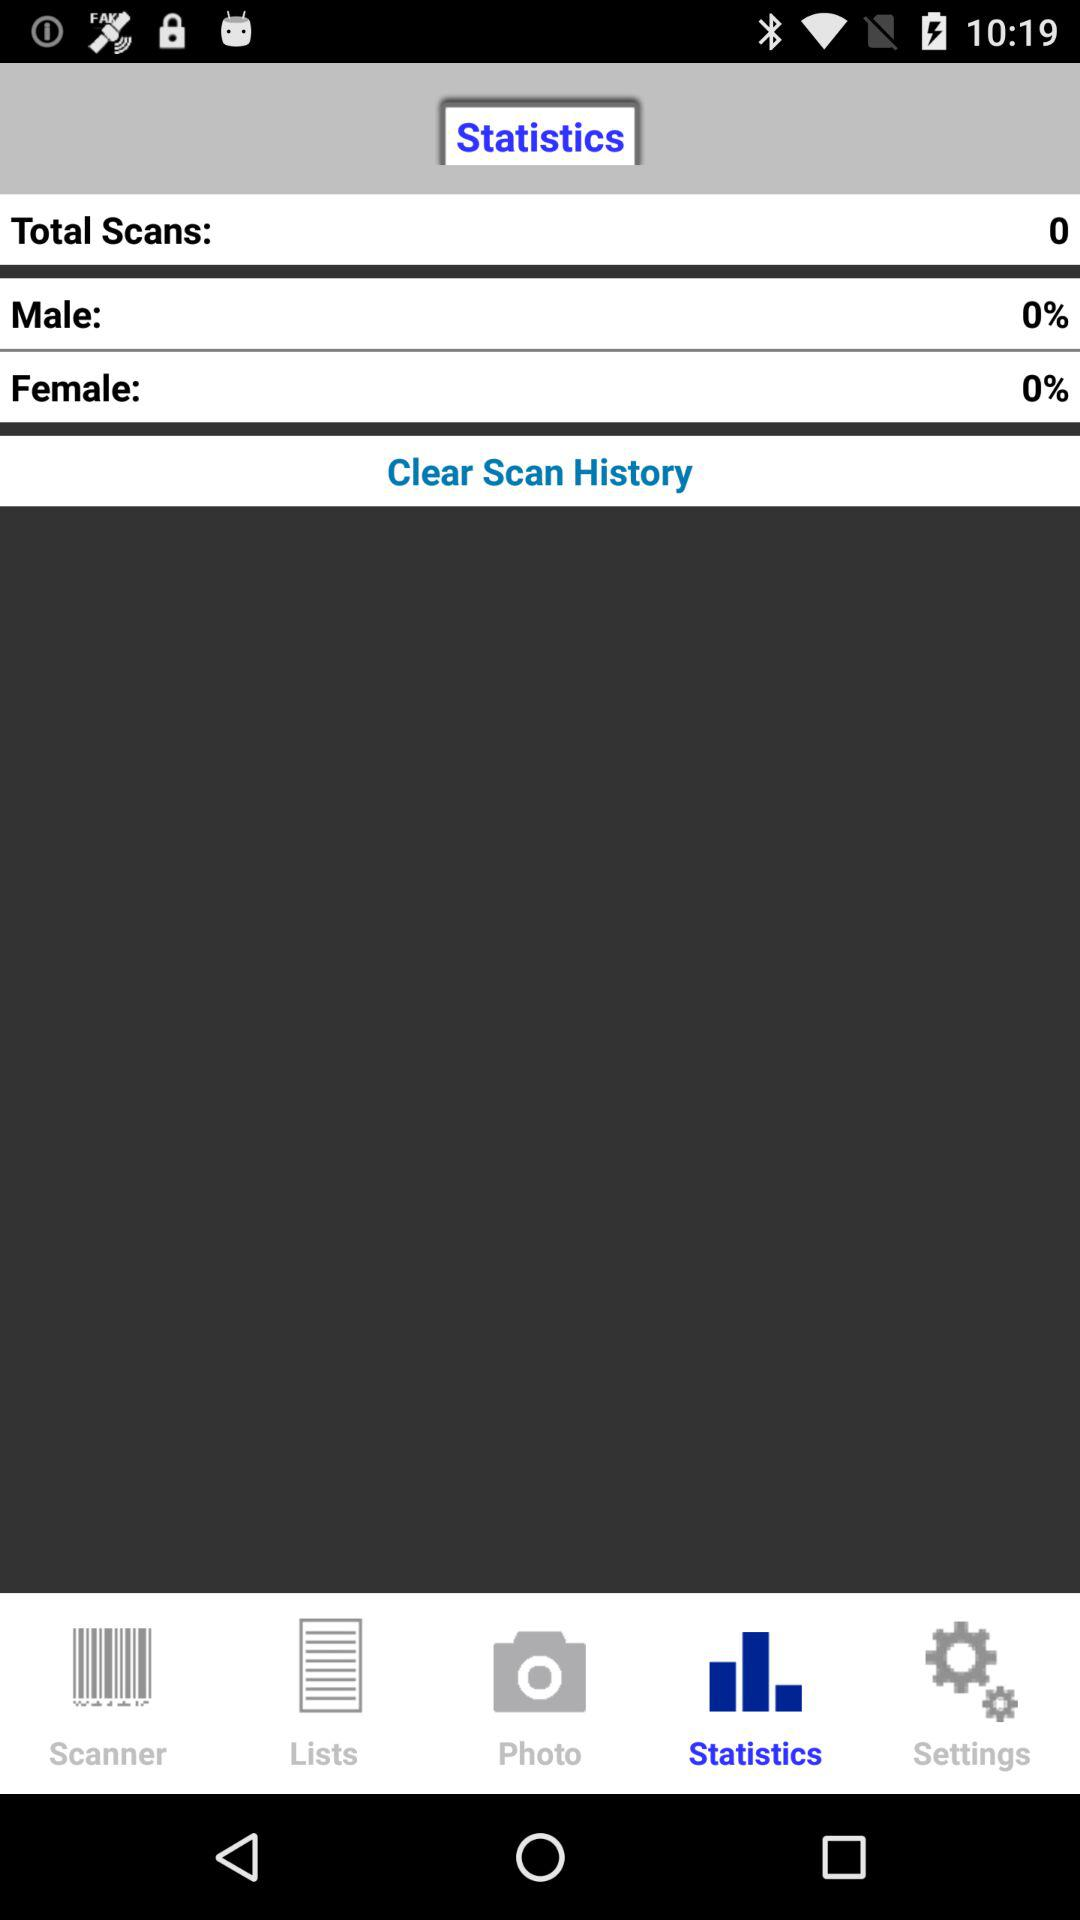What is the percentage of male? The percentage is 0. 